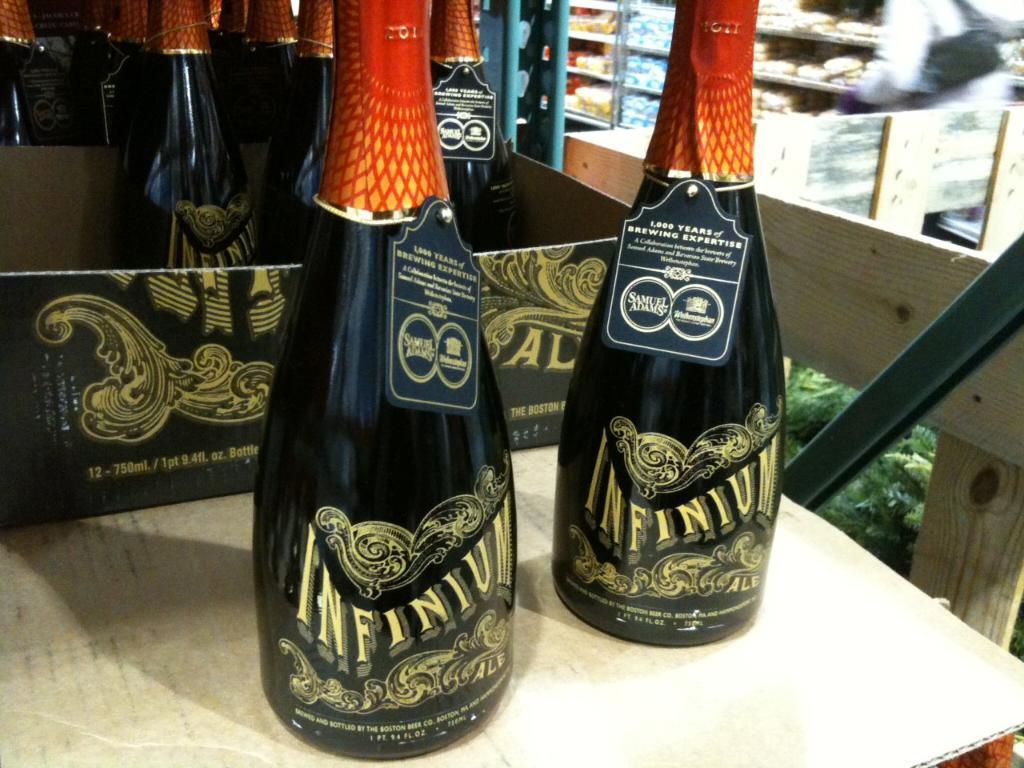What is the brand name of the alcohol?
Your answer should be compact. Infinium. 